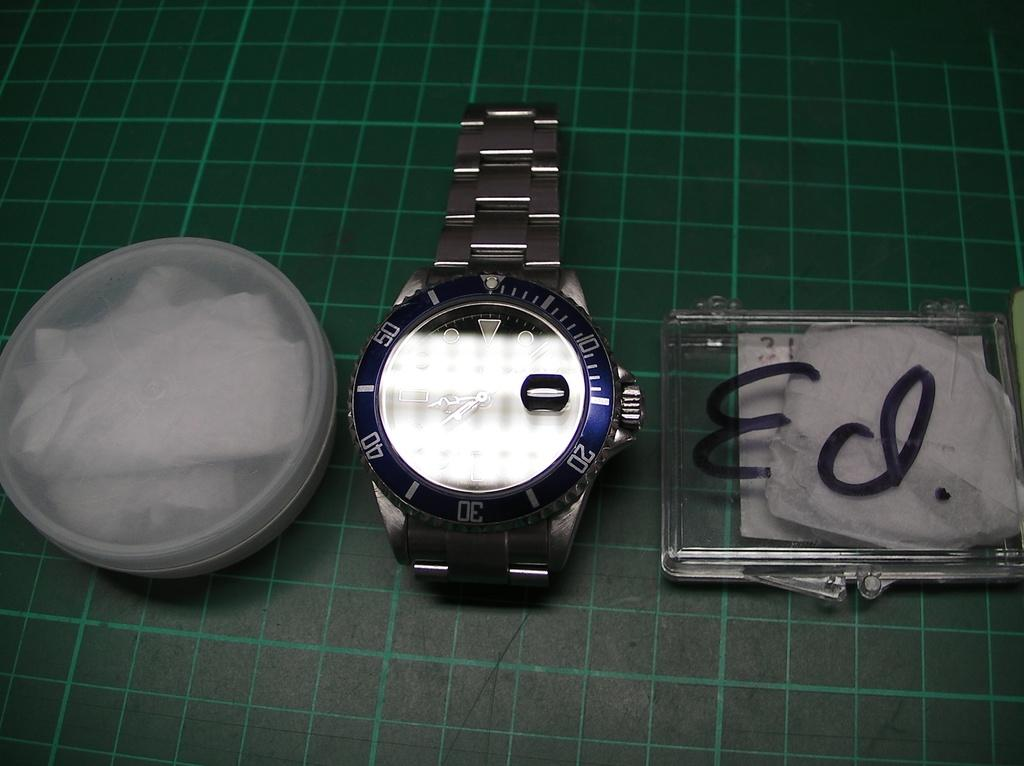Provide a one-sentence caption for the provided image. A watch sits next to a clear case with the name Ed written on it in marker. 